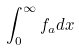Convert formula to latex. <formula><loc_0><loc_0><loc_500><loc_500>\int _ { 0 } ^ { \infty } f _ { a } d x</formula> 